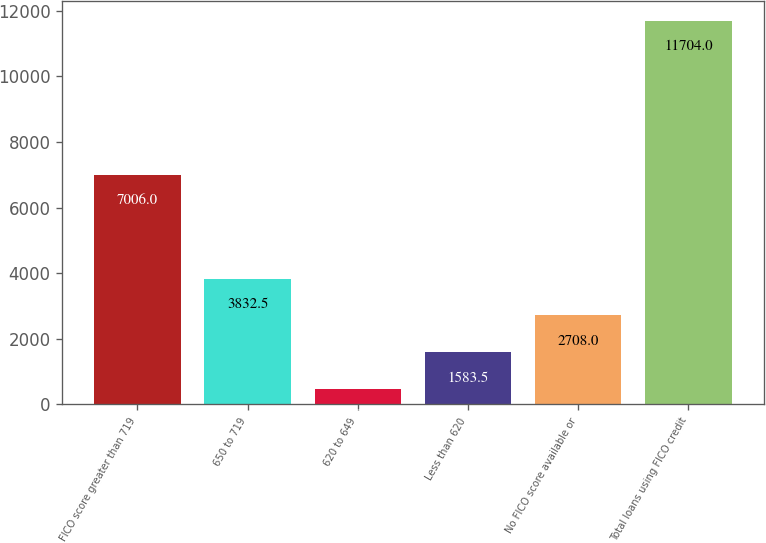<chart> <loc_0><loc_0><loc_500><loc_500><bar_chart><fcel>FICO score greater than 719<fcel>650 to 719<fcel>620 to 649<fcel>Less than 620<fcel>No FICO score available or<fcel>Total loans using FICO credit<nl><fcel>7006<fcel>3832.5<fcel>459<fcel>1583.5<fcel>2708<fcel>11704<nl></chart> 